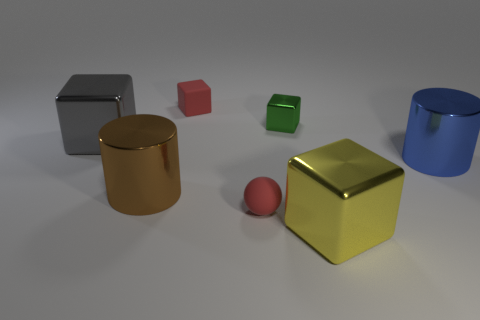What number of things are either things behind the small green cube or metal cubes?
Offer a terse response. 4. The tiny metallic block has what color?
Provide a short and direct response. Green. There is a red thing behind the gray metallic cube; what material is it?
Provide a short and direct response. Rubber. Does the large yellow metallic thing have the same shape as the small matte thing that is behind the blue thing?
Give a very brief answer. Yes. Is the number of small green cubes greater than the number of small shiny cylinders?
Your answer should be very brief. Yes. Are there any other things of the same color as the rubber cube?
Ensure brevity in your answer.  Yes. There is a green object that is made of the same material as the blue cylinder; what shape is it?
Your answer should be compact. Cube. What is the material of the cylinder that is to the left of the yellow metallic cube in front of the green thing?
Offer a terse response. Metal. Is the shape of the small thing in front of the large brown metallic cylinder the same as  the big blue object?
Offer a very short reply. No. Is the number of large metal cylinders to the left of the big yellow block greater than the number of yellow cylinders?
Give a very brief answer. Yes. 